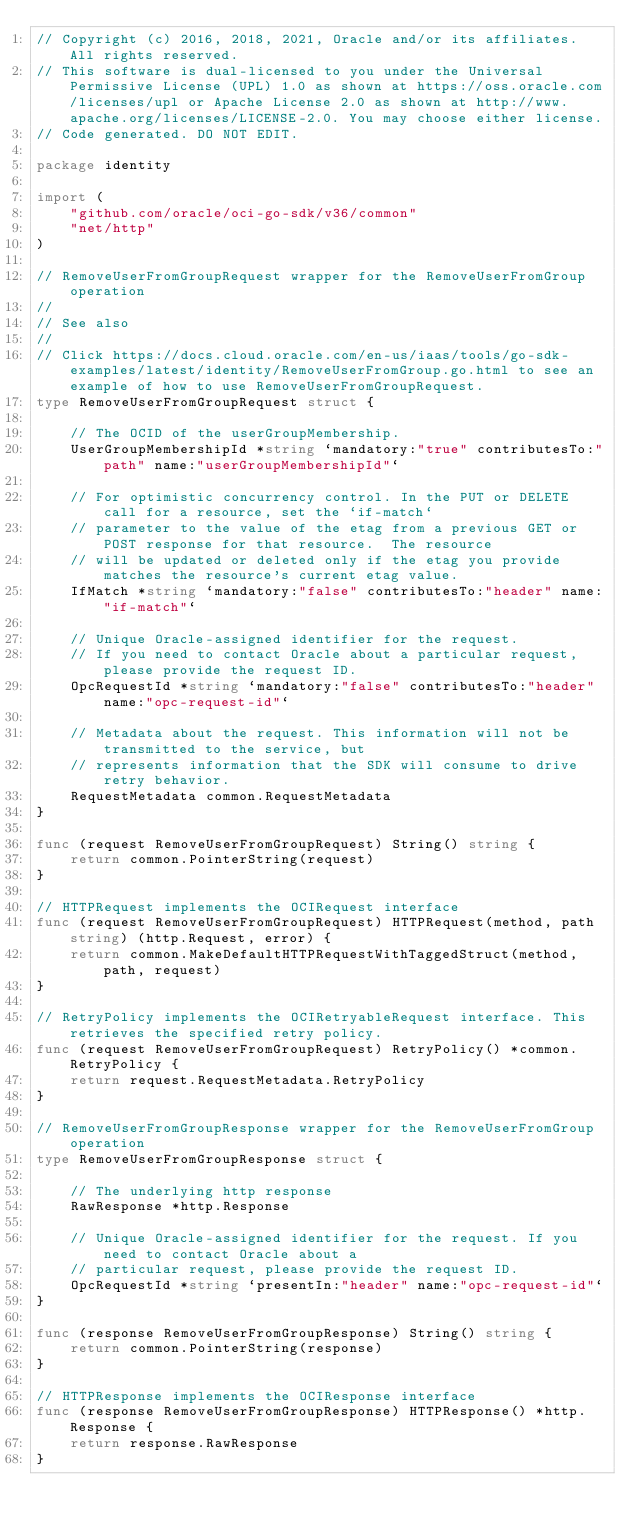Convert code to text. <code><loc_0><loc_0><loc_500><loc_500><_Go_>// Copyright (c) 2016, 2018, 2021, Oracle and/or its affiliates.  All rights reserved.
// This software is dual-licensed to you under the Universal Permissive License (UPL) 1.0 as shown at https://oss.oracle.com/licenses/upl or Apache License 2.0 as shown at http://www.apache.org/licenses/LICENSE-2.0. You may choose either license.
// Code generated. DO NOT EDIT.

package identity

import (
	"github.com/oracle/oci-go-sdk/v36/common"
	"net/http"
)

// RemoveUserFromGroupRequest wrapper for the RemoveUserFromGroup operation
//
// See also
//
// Click https://docs.cloud.oracle.com/en-us/iaas/tools/go-sdk-examples/latest/identity/RemoveUserFromGroup.go.html to see an example of how to use RemoveUserFromGroupRequest.
type RemoveUserFromGroupRequest struct {

	// The OCID of the userGroupMembership.
	UserGroupMembershipId *string `mandatory:"true" contributesTo:"path" name:"userGroupMembershipId"`

	// For optimistic concurrency control. In the PUT or DELETE call for a resource, set the `if-match`
	// parameter to the value of the etag from a previous GET or POST response for that resource.  The resource
	// will be updated or deleted only if the etag you provide matches the resource's current etag value.
	IfMatch *string `mandatory:"false" contributesTo:"header" name:"if-match"`

	// Unique Oracle-assigned identifier for the request.
	// If you need to contact Oracle about a particular request, please provide the request ID.
	OpcRequestId *string `mandatory:"false" contributesTo:"header" name:"opc-request-id"`

	// Metadata about the request. This information will not be transmitted to the service, but
	// represents information that the SDK will consume to drive retry behavior.
	RequestMetadata common.RequestMetadata
}

func (request RemoveUserFromGroupRequest) String() string {
	return common.PointerString(request)
}

// HTTPRequest implements the OCIRequest interface
func (request RemoveUserFromGroupRequest) HTTPRequest(method, path string) (http.Request, error) {
	return common.MakeDefaultHTTPRequestWithTaggedStruct(method, path, request)
}

// RetryPolicy implements the OCIRetryableRequest interface. This retrieves the specified retry policy.
func (request RemoveUserFromGroupRequest) RetryPolicy() *common.RetryPolicy {
	return request.RequestMetadata.RetryPolicy
}

// RemoveUserFromGroupResponse wrapper for the RemoveUserFromGroup operation
type RemoveUserFromGroupResponse struct {

	// The underlying http response
	RawResponse *http.Response

	// Unique Oracle-assigned identifier for the request. If you need to contact Oracle about a
	// particular request, please provide the request ID.
	OpcRequestId *string `presentIn:"header" name:"opc-request-id"`
}

func (response RemoveUserFromGroupResponse) String() string {
	return common.PointerString(response)
}

// HTTPResponse implements the OCIResponse interface
func (response RemoveUserFromGroupResponse) HTTPResponse() *http.Response {
	return response.RawResponse
}
</code> 